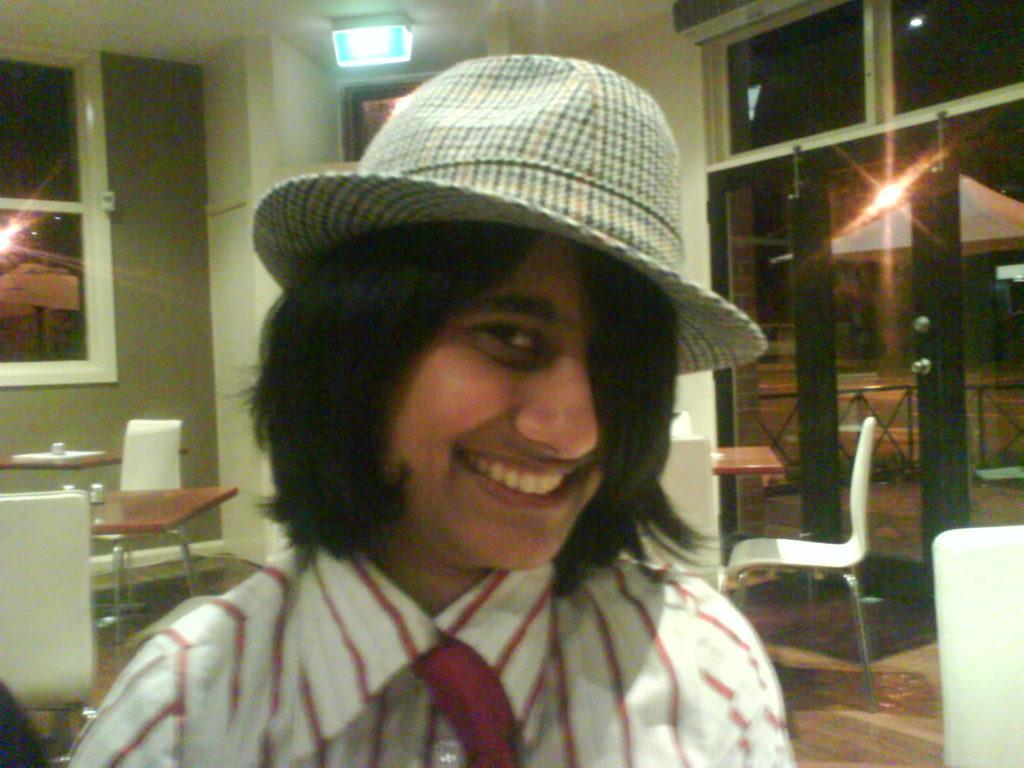Who is the main subject in the image? There is a person in the center of the image. What is the person doing in the image? The person is smiling. What type of clothing is the person wearing? The person is wearing a cap. What can be seen in the left corner of the image? There is a table and chairs, as well as a wall with a glass window in the left corner of the image. How many passengers are visible in the image? There are no passengers present in the image; it only features a person wearing a cap. What type of apparel is the mother wearing in the image? There is no mother present in the image, and therefore no apparel can be attributed to her. 